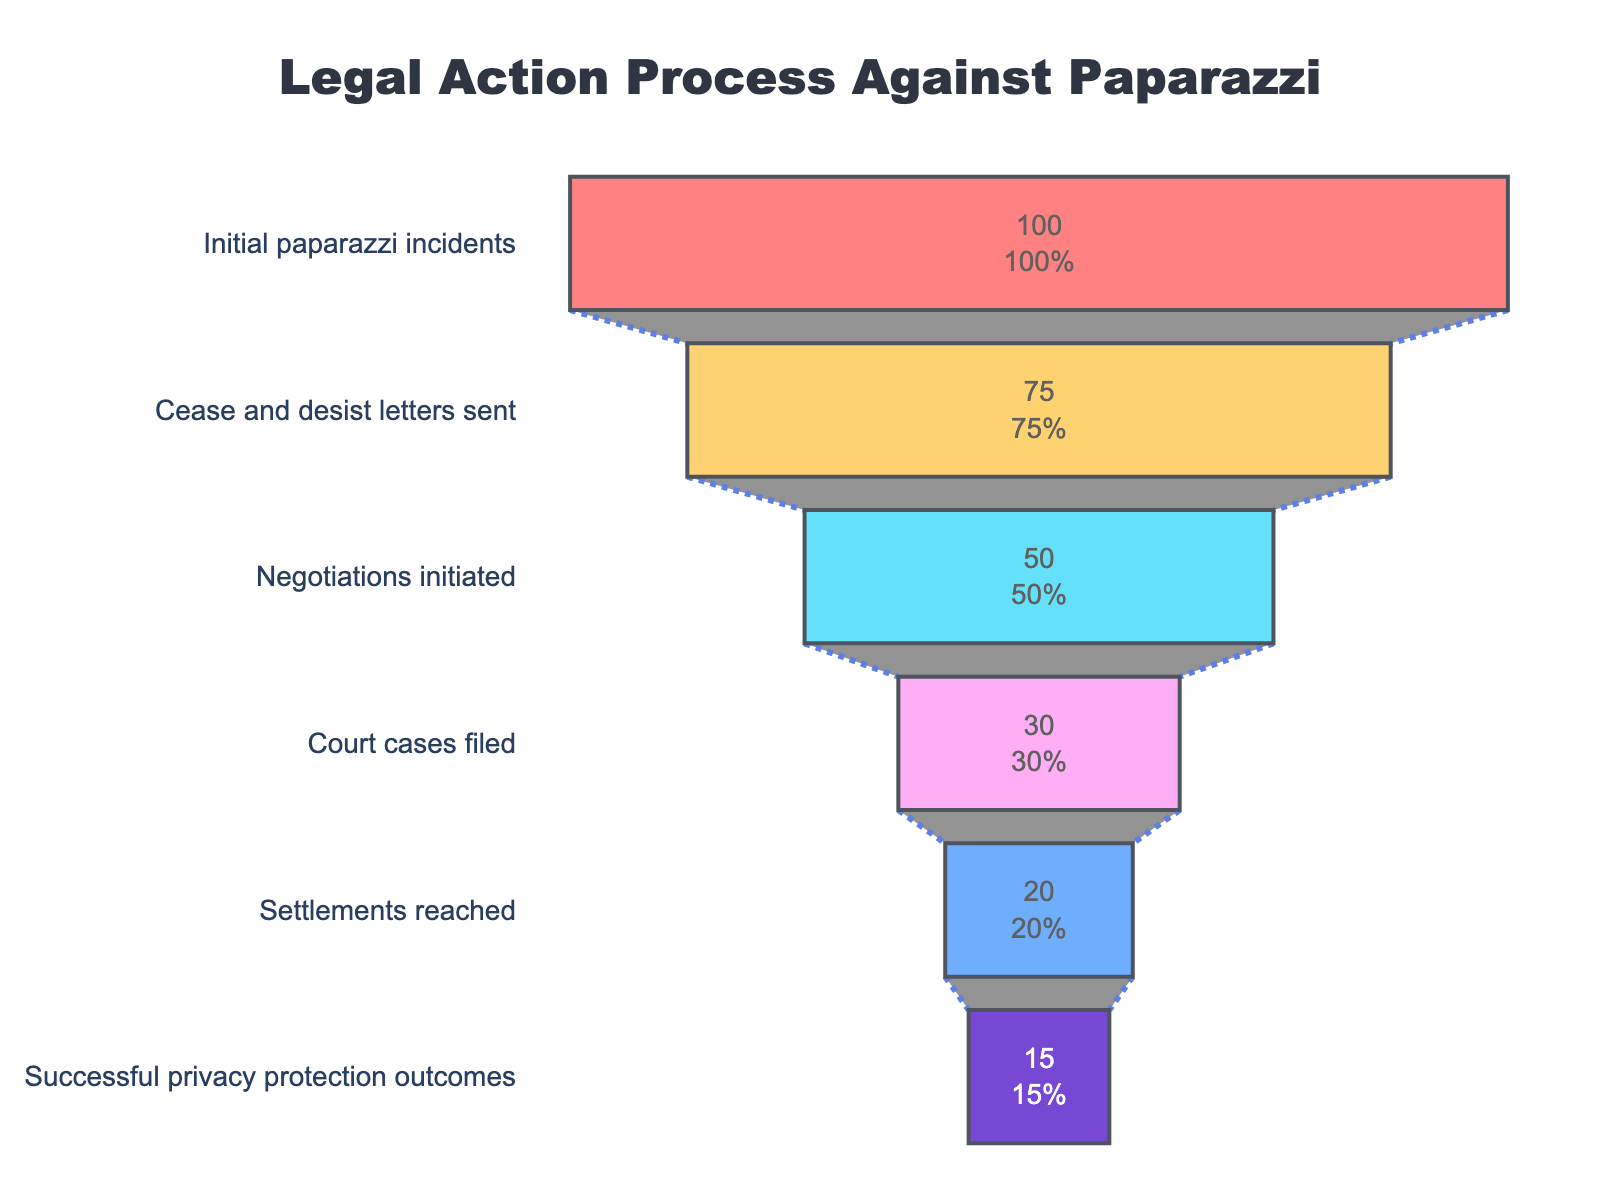What is the title of the figure? The title is located at the top center of the chart, prominently displayed to describe the figure’s subject.
Answer: Legal Action Process Against Paparazzi How many initial paparazzi incidents are reported in the figure? The value of the topmost step in the funnel chart represents the initial paparazzi incidents.
Answer: 100 What percentage of cease and desist letters were sent out of the initial paparazzi incidents? Divide the number of cease and desist letters (75) by the initial paparazzi incidents (100) and multiply by 100 to get the percentage. (75/100)*100
Answer: 75% Which step has the smallest number of cases in the funnel? By observing the funnel chart, the step closest to the bottom with the fewest cases is the one with the smallest number.
Answer: Successful privacy protection outcomes How many cases move from cease and desist letters to negotiations initiated? Subtract the number of negotiations initiated from the number of cease and desist letters sent. 75 - 50
Answer: 25 Out of the court cases filed, what percentage resulted in successful privacy protection outcomes? Divide the number of successful outcomes (15) by the court cases filed (30) and multiply by 100. (15/30)*100
Answer: 50% Compare the number of settlements reached to court cases filed. Which is larger and by how much? Subtraction shows the difference between court cases filed (30) and settlements reached (20). 30 - 20 = 10. Court cases filed is larger.
Answer: Court cases filed by 10 At which step do we see the largest drop in the number of cases? By calculating the differences between successive steps, the largest drop is observed from court cases filed (30) to settlements reached (20). (30-20 = 10)
Answer: From negotiations initiated to court cases filed What is the percentage change from the initial incidents to successful privacy protection outcomes? Calculate the percentage change from 100 to 15, which is ((100-15)/100)*100.
Answer: 85% Is the drop in cases from negotiations initiated to court cases filed larger than from settlements reached to successful privacy protection outcomes? Calculate the drop from 50 to 30 (20 cases) and from 20 to 15 (5 cases). Compare these two drops, 20 > 5.
Answer: Yes 